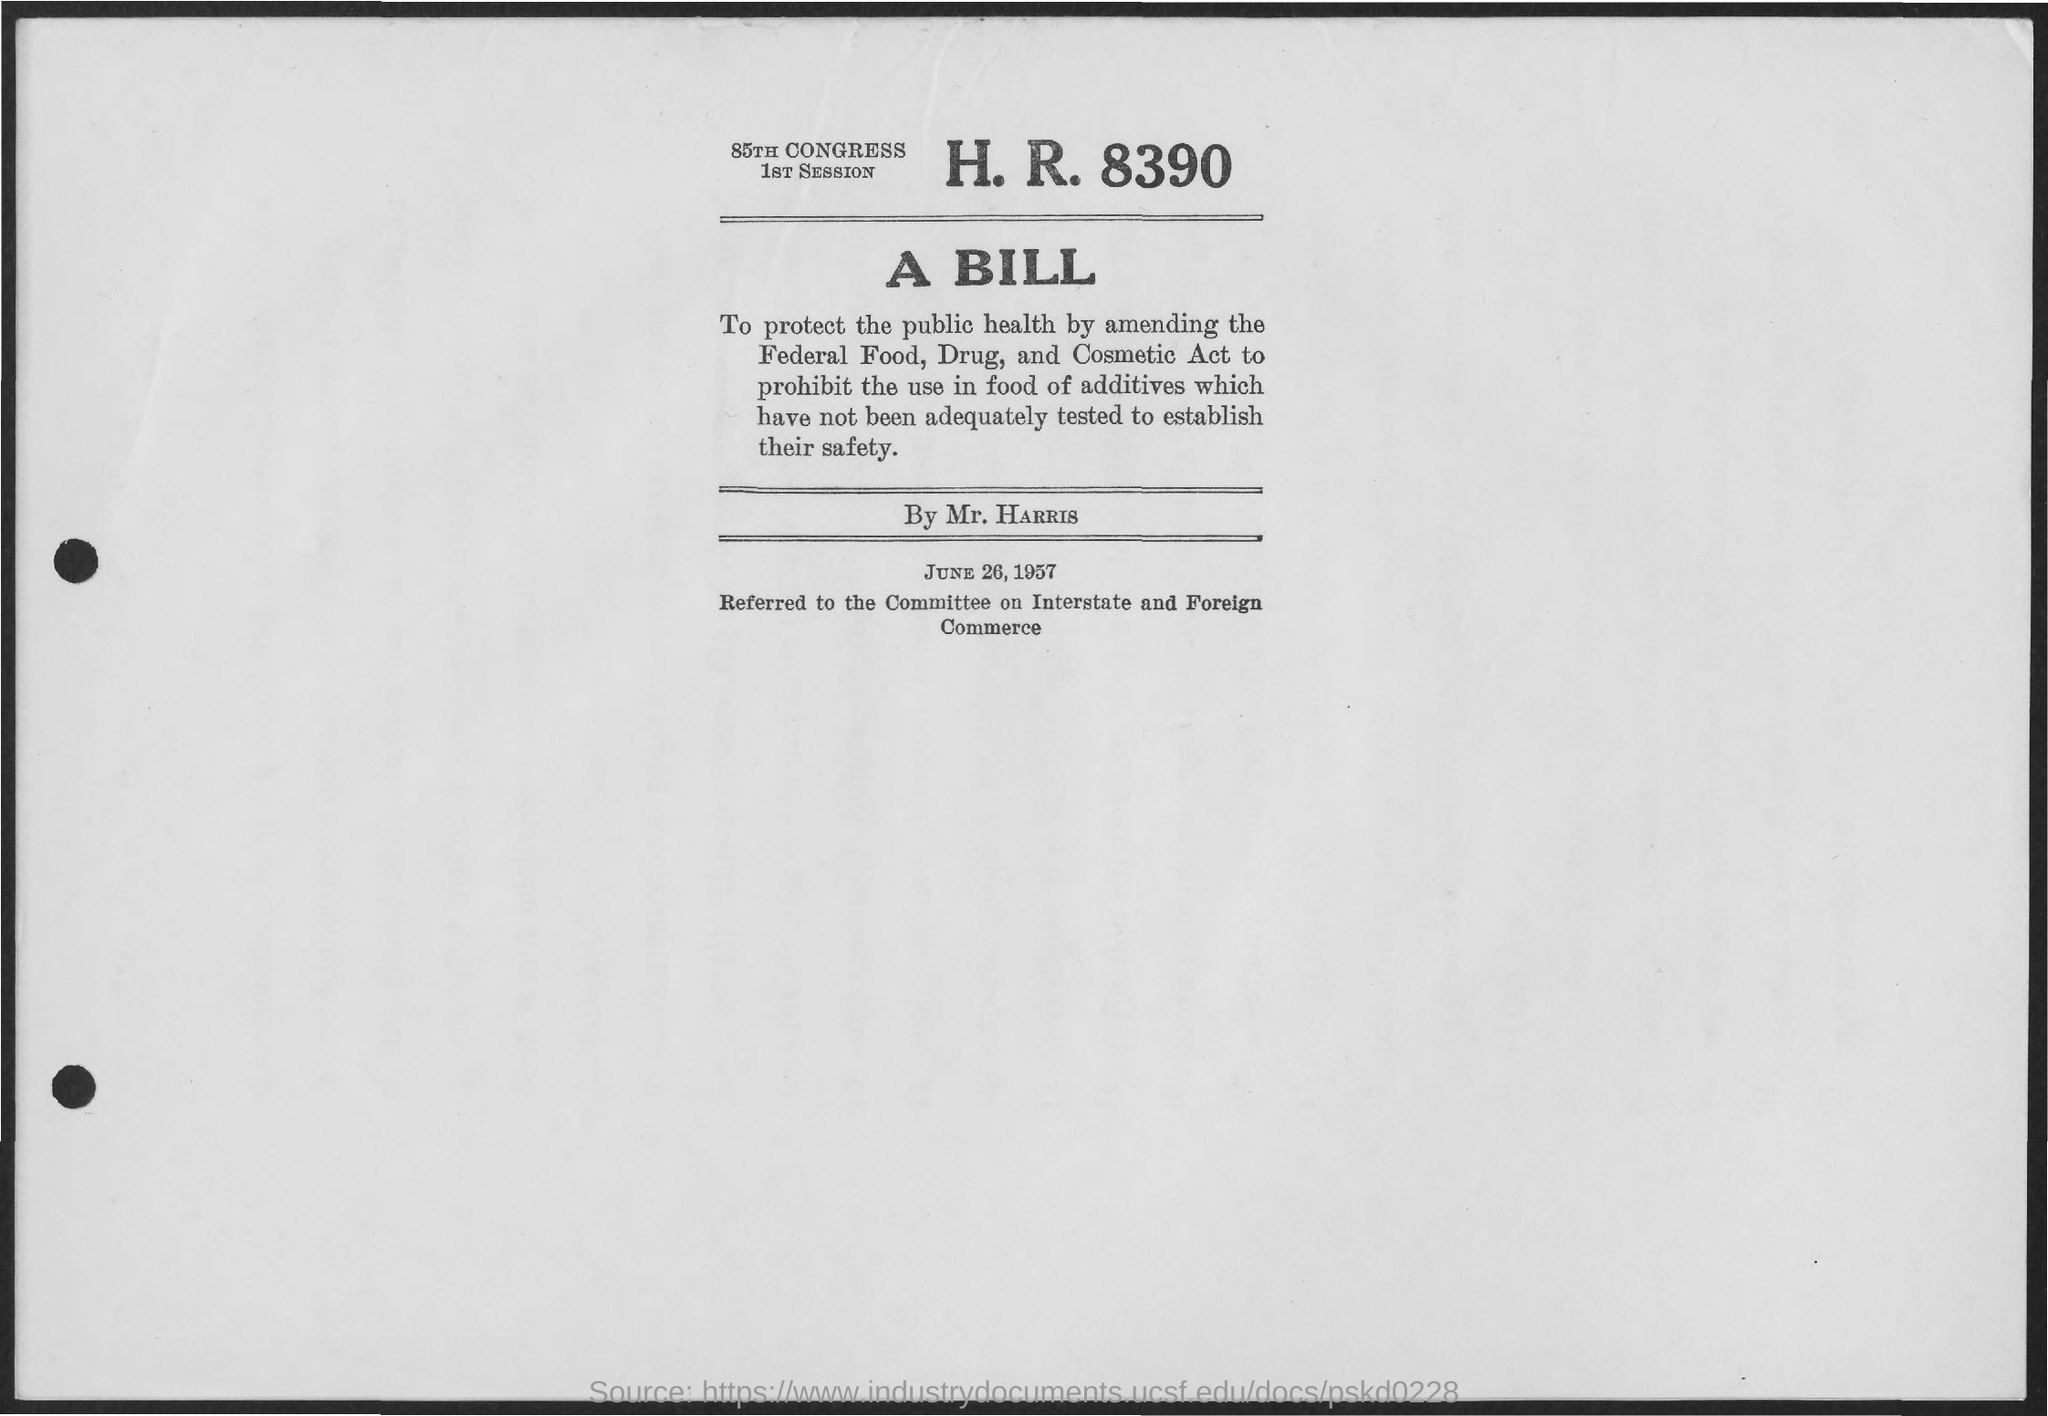What is h.r. number?
Ensure brevity in your answer.  8390. A bill in this page is proposed by?
Offer a very short reply. Mr. Harris. What is date mentioned in the page?
Offer a very short reply. June 26,1957. In which session is this bill introduced in 85th congress?
Your answer should be very brief. 1st session. 